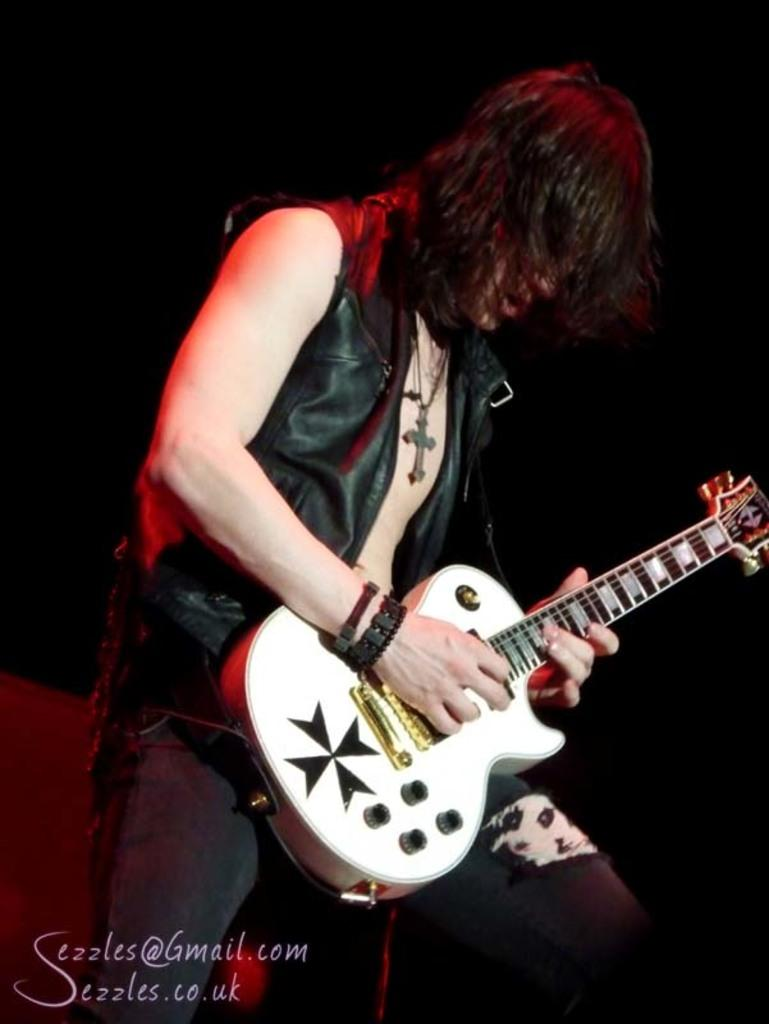Who is the main subject in the image? There is a man in the image. Where is the man positioned in the image? The man is standing in the center of the image. What is the man holding in his hand? The man is holding a musical instrument in his hand. How many deer can be seen in the image? There are no deer present in the image. What direction does the man need to turn to face the team? There is no team or specific direction mentioned in the image, so it is not possible to answer this question. 